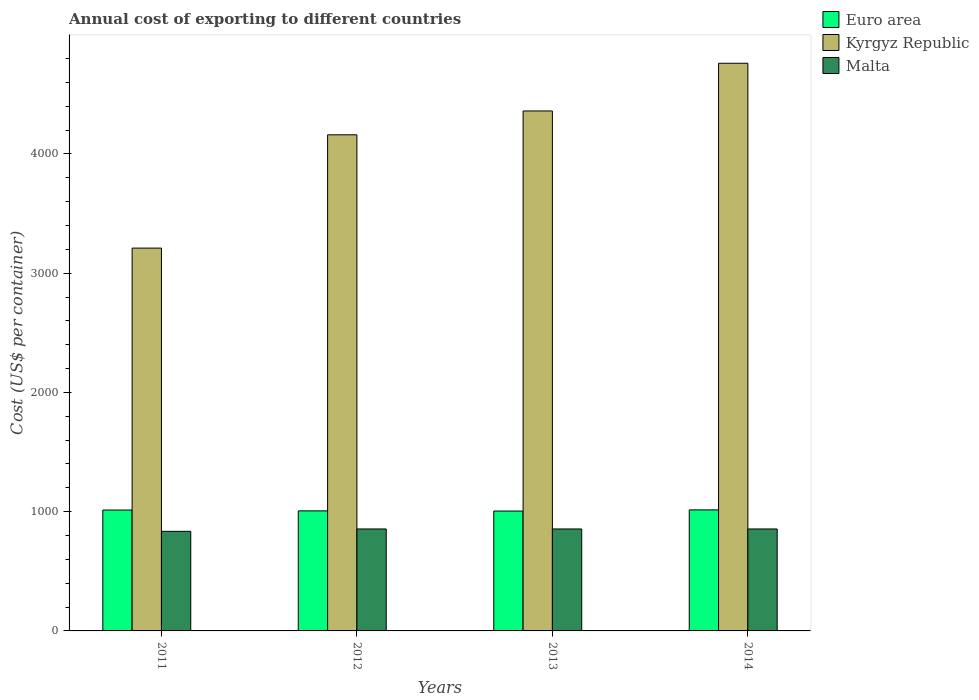How many different coloured bars are there?
Your answer should be compact. 3. How many groups of bars are there?
Ensure brevity in your answer.  4. Are the number of bars per tick equal to the number of legend labels?
Provide a succinct answer. Yes. How many bars are there on the 4th tick from the left?
Your answer should be compact. 3. How many bars are there on the 4th tick from the right?
Your answer should be compact. 3. In how many cases, is the number of bars for a given year not equal to the number of legend labels?
Provide a short and direct response. 0. What is the total annual cost of exporting in Malta in 2014?
Offer a terse response. 855. Across all years, what is the maximum total annual cost of exporting in Euro area?
Make the answer very short. 1015. Across all years, what is the minimum total annual cost of exporting in Kyrgyz Republic?
Your response must be concise. 3210. In which year was the total annual cost of exporting in Malta maximum?
Your answer should be very brief. 2012. What is the total total annual cost of exporting in Malta in the graph?
Make the answer very short. 3400. What is the difference between the total annual cost of exporting in Euro area in 2011 and that in 2013?
Provide a succinct answer. 8.42. What is the difference between the total annual cost of exporting in Malta in 2011 and the total annual cost of exporting in Kyrgyz Republic in 2013?
Your answer should be compact. -3525. What is the average total annual cost of exporting in Malta per year?
Your answer should be compact. 850. In the year 2012, what is the difference between the total annual cost of exporting in Euro area and total annual cost of exporting in Kyrgyz Republic?
Provide a short and direct response. -3153.32. In how many years, is the total annual cost of exporting in Kyrgyz Republic greater than 2200 US$?
Your answer should be compact. 4. What is the ratio of the total annual cost of exporting in Euro area in 2012 to that in 2013?
Offer a terse response. 1. Is the difference between the total annual cost of exporting in Euro area in 2011 and 2014 greater than the difference between the total annual cost of exporting in Kyrgyz Republic in 2011 and 2014?
Your response must be concise. Yes. What is the difference between the highest and the lowest total annual cost of exporting in Kyrgyz Republic?
Offer a terse response. 1550. In how many years, is the total annual cost of exporting in Malta greater than the average total annual cost of exporting in Malta taken over all years?
Ensure brevity in your answer.  3. Is the sum of the total annual cost of exporting in Euro area in 2011 and 2013 greater than the maximum total annual cost of exporting in Malta across all years?
Give a very brief answer. Yes. What does the 1st bar from the left in 2012 represents?
Offer a terse response. Euro area. Is it the case that in every year, the sum of the total annual cost of exporting in Malta and total annual cost of exporting in Euro area is greater than the total annual cost of exporting in Kyrgyz Republic?
Provide a succinct answer. No. Are the values on the major ticks of Y-axis written in scientific E-notation?
Offer a terse response. No. Does the graph contain any zero values?
Keep it short and to the point. No. Does the graph contain grids?
Keep it short and to the point. No. How are the legend labels stacked?
Your response must be concise. Vertical. What is the title of the graph?
Give a very brief answer. Annual cost of exporting to different countries. Does "Aruba" appear as one of the legend labels in the graph?
Provide a succinct answer. No. What is the label or title of the X-axis?
Your response must be concise. Years. What is the label or title of the Y-axis?
Your response must be concise. Cost (US$ per container). What is the Cost (US$ per container) of Euro area in 2011?
Make the answer very short. 1013.68. What is the Cost (US$ per container) of Kyrgyz Republic in 2011?
Keep it short and to the point. 3210. What is the Cost (US$ per container) in Malta in 2011?
Your answer should be very brief. 835. What is the Cost (US$ per container) in Euro area in 2012?
Keep it short and to the point. 1006.68. What is the Cost (US$ per container) in Kyrgyz Republic in 2012?
Offer a terse response. 4160. What is the Cost (US$ per container) of Malta in 2012?
Offer a terse response. 855. What is the Cost (US$ per container) of Euro area in 2013?
Your answer should be very brief. 1005.26. What is the Cost (US$ per container) in Kyrgyz Republic in 2013?
Your response must be concise. 4360. What is the Cost (US$ per container) in Malta in 2013?
Make the answer very short. 855. What is the Cost (US$ per container) of Euro area in 2014?
Provide a succinct answer. 1015. What is the Cost (US$ per container) in Kyrgyz Republic in 2014?
Offer a very short reply. 4760. What is the Cost (US$ per container) of Malta in 2014?
Your answer should be compact. 855. Across all years, what is the maximum Cost (US$ per container) of Euro area?
Your answer should be very brief. 1015. Across all years, what is the maximum Cost (US$ per container) in Kyrgyz Republic?
Provide a short and direct response. 4760. Across all years, what is the maximum Cost (US$ per container) in Malta?
Offer a very short reply. 855. Across all years, what is the minimum Cost (US$ per container) of Euro area?
Your answer should be very brief. 1005.26. Across all years, what is the minimum Cost (US$ per container) in Kyrgyz Republic?
Keep it short and to the point. 3210. Across all years, what is the minimum Cost (US$ per container) of Malta?
Your answer should be compact. 835. What is the total Cost (US$ per container) in Euro area in the graph?
Your answer should be very brief. 4040.63. What is the total Cost (US$ per container) of Kyrgyz Republic in the graph?
Your answer should be very brief. 1.65e+04. What is the total Cost (US$ per container) in Malta in the graph?
Your answer should be compact. 3400. What is the difference between the Cost (US$ per container) of Kyrgyz Republic in 2011 and that in 2012?
Ensure brevity in your answer.  -950. What is the difference between the Cost (US$ per container) of Euro area in 2011 and that in 2013?
Give a very brief answer. 8.42. What is the difference between the Cost (US$ per container) in Kyrgyz Republic in 2011 and that in 2013?
Keep it short and to the point. -1150. What is the difference between the Cost (US$ per container) of Euro area in 2011 and that in 2014?
Make the answer very short. -1.32. What is the difference between the Cost (US$ per container) of Kyrgyz Republic in 2011 and that in 2014?
Provide a succinct answer. -1550. What is the difference between the Cost (US$ per container) in Malta in 2011 and that in 2014?
Ensure brevity in your answer.  -20. What is the difference between the Cost (US$ per container) in Euro area in 2012 and that in 2013?
Keep it short and to the point. 1.42. What is the difference between the Cost (US$ per container) of Kyrgyz Republic in 2012 and that in 2013?
Keep it short and to the point. -200. What is the difference between the Cost (US$ per container) in Malta in 2012 and that in 2013?
Your answer should be very brief. 0. What is the difference between the Cost (US$ per container) of Euro area in 2012 and that in 2014?
Provide a succinct answer. -8.32. What is the difference between the Cost (US$ per container) of Kyrgyz Republic in 2012 and that in 2014?
Provide a succinct answer. -600. What is the difference between the Cost (US$ per container) of Malta in 2012 and that in 2014?
Your response must be concise. 0. What is the difference between the Cost (US$ per container) in Euro area in 2013 and that in 2014?
Make the answer very short. -9.74. What is the difference between the Cost (US$ per container) of Kyrgyz Republic in 2013 and that in 2014?
Your answer should be compact. -400. What is the difference between the Cost (US$ per container) in Malta in 2013 and that in 2014?
Offer a very short reply. 0. What is the difference between the Cost (US$ per container) in Euro area in 2011 and the Cost (US$ per container) in Kyrgyz Republic in 2012?
Offer a terse response. -3146.32. What is the difference between the Cost (US$ per container) of Euro area in 2011 and the Cost (US$ per container) of Malta in 2012?
Your answer should be very brief. 158.68. What is the difference between the Cost (US$ per container) of Kyrgyz Republic in 2011 and the Cost (US$ per container) of Malta in 2012?
Ensure brevity in your answer.  2355. What is the difference between the Cost (US$ per container) of Euro area in 2011 and the Cost (US$ per container) of Kyrgyz Republic in 2013?
Provide a short and direct response. -3346.32. What is the difference between the Cost (US$ per container) of Euro area in 2011 and the Cost (US$ per container) of Malta in 2013?
Offer a terse response. 158.68. What is the difference between the Cost (US$ per container) in Kyrgyz Republic in 2011 and the Cost (US$ per container) in Malta in 2013?
Ensure brevity in your answer.  2355. What is the difference between the Cost (US$ per container) in Euro area in 2011 and the Cost (US$ per container) in Kyrgyz Republic in 2014?
Offer a very short reply. -3746.32. What is the difference between the Cost (US$ per container) in Euro area in 2011 and the Cost (US$ per container) in Malta in 2014?
Provide a succinct answer. 158.68. What is the difference between the Cost (US$ per container) in Kyrgyz Republic in 2011 and the Cost (US$ per container) in Malta in 2014?
Provide a short and direct response. 2355. What is the difference between the Cost (US$ per container) of Euro area in 2012 and the Cost (US$ per container) of Kyrgyz Republic in 2013?
Keep it short and to the point. -3353.32. What is the difference between the Cost (US$ per container) of Euro area in 2012 and the Cost (US$ per container) of Malta in 2013?
Offer a terse response. 151.68. What is the difference between the Cost (US$ per container) of Kyrgyz Republic in 2012 and the Cost (US$ per container) of Malta in 2013?
Your response must be concise. 3305. What is the difference between the Cost (US$ per container) of Euro area in 2012 and the Cost (US$ per container) of Kyrgyz Republic in 2014?
Provide a succinct answer. -3753.32. What is the difference between the Cost (US$ per container) in Euro area in 2012 and the Cost (US$ per container) in Malta in 2014?
Offer a very short reply. 151.68. What is the difference between the Cost (US$ per container) of Kyrgyz Republic in 2012 and the Cost (US$ per container) of Malta in 2014?
Offer a terse response. 3305. What is the difference between the Cost (US$ per container) of Euro area in 2013 and the Cost (US$ per container) of Kyrgyz Republic in 2014?
Make the answer very short. -3754.74. What is the difference between the Cost (US$ per container) in Euro area in 2013 and the Cost (US$ per container) in Malta in 2014?
Give a very brief answer. 150.26. What is the difference between the Cost (US$ per container) in Kyrgyz Republic in 2013 and the Cost (US$ per container) in Malta in 2014?
Keep it short and to the point. 3505. What is the average Cost (US$ per container) in Euro area per year?
Keep it short and to the point. 1010.16. What is the average Cost (US$ per container) of Kyrgyz Republic per year?
Give a very brief answer. 4122.5. What is the average Cost (US$ per container) of Malta per year?
Provide a succinct answer. 850. In the year 2011, what is the difference between the Cost (US$ per container) of Euro area and Cost (US$ per container) of Kyrgyz Republic?
Keep it short and to the point. -2196.32. In the year 2011, what is the difference between the Cost (US$ per container) of Euro area and Cost (US$ per container) of Malta?
Give a very brief answer. 178.68. In the year 2011, what is the difference between the Cost (US$ per container) of Kyrgyz Republic and Cost (US$ per container) of Malta?
Your response must be concise. 2375. In the year 2012, what is the difference between the Cost (US$ per container) of Euro area and Cost (US$ per container) of Kyrgyz Republic?
Your answer should be very brief. -3153.32. In the year 2012, what is the difference between the Cost (US$ per container) of Euro area and Cost (US$ per container) of Malta?
Ensure brevity in your answer.  151.68. In the year 2012, what is the difference between the Cost (US$ per container) in Kyrgyz Republic and Cost (US$ per container) in Malta?
Give a very brief answer. 3305. In the year 2013, what is the difference between the Cost (US$ per container) of Euro area and Cost (US$ per container) of Kyrgyz Republic?
Make the answer very short. -3354.74. In the year 2013, what is the difference between the Cost (US$ per container) of Euro area and Cost (US$ per container) of Malta?
Provide a short and direct response. 150.26. In the year 2013, what is the difference between the Cost (US$ per container) of Kyrgyz Republic and Cost (US$ per container) of Malta?
Your answer should be compact. 3505. In the year 2014, what is the difference between the Cost (US$ per container) in Euro area and Cost (US$ per container) in Kyrgyz Republic?
Give a very brief answer. -3745. In the year 2014, what is the difference between the Cost (US$ per container) in Euro area and Cost (US$ per container) in Malta?
Make the answer very short. 160. In the year 2014, what is the difference between the Cost (US$ per container) of Kyrgyz Republic and Cost (US$ per container) of Malta?
Provide a short and direct response. 3905. What is the ratio of the Cost (US$ per container) in Euro area in 2011 to that in 2012?
Give a very brief answer. 1.01. What is the ratio of the Cost (US$ per container) in Kyrgyz Republic in 2011 to that in 2012?
Give a very brief answer. 0.77. What is the ratio of the Cost (US$ per container) of Malta in 2011 to that in 2012?
Your answer should be compact. 0.98. What is the ratio of the Cost (US$ per container) of Euro area in 2011 to that in 2013?
Give a very brief answer. 1.01. What is the ratio of the Cost (US$ per container) in Kyrgyz Republic in 2011 to that in 2013?
Ensure brevity in your answer.  0.74. What is the ratio of the Cost (US$ per container) in Malta in 2011 to that in 2013?
Make the answer very short. 0.98. What is the ratio of the Cost (US$ per container) of Euro area in 2011 to that in 2014?
Ensure brevity in your answer.  1. What is the ratio of the Cost (US$ per container) in Kyrgyz Republic in 2011 to that in 2014?
Provide a succinct answer. 0.67. What is the ratio of the Cost (US$ per container) in Malta in 2011 to that in 2014?
Your answer should be very brief. 0.98. What is the ratio of the Cost (US$ per container) in Euro area in 2012 to that in 2013?
Your response must be concise. 1. What is the ratio of the Cost (US$ per container) of Kyrgyz Republic in 2012 to that in 2013?
Keep it short and to the point. 0.95. What is the ratio of the Cost (US$ per container) in Kyrgyz Republic in 2012 to that in 2014?
Your answer should be compact. 0.87. What is the ratio of the Cost (US$ per container) in Euro area in 2013 to that in 2014?
Provide a succinct answer. 0.99. What is the ratio of the Cost (US$ per container) in Kyrgyz Republic in 2013 to that in 2014?
Your answer should be compact. 0.92. What is the ratio of the Cost (US$ per container) of Malta in 2013 to that in 2014?
Your response must be concise. 1. What is the difference between the highest and the second highest Cost (US$ per container) of Euro area?
Give a very brief answer. 1.32. What is the difference between the highest and the second highest Cost (US$ per container) in Kyrgyz Republic?
Make the answer very short. 400. What is the difference between the highest and the lowest Cost (US$ per container) in Euro area?
Provide a short and direct response. 9.74. What is the difference between the highest and the lowest Cost (US$ per container) of Kyrgyz Republic?
Keep it short and to the point. 1550. What is the difference between the highest and the lowest Cost (US$ per container) in Malta?
Provide a short and direct response. 20. 